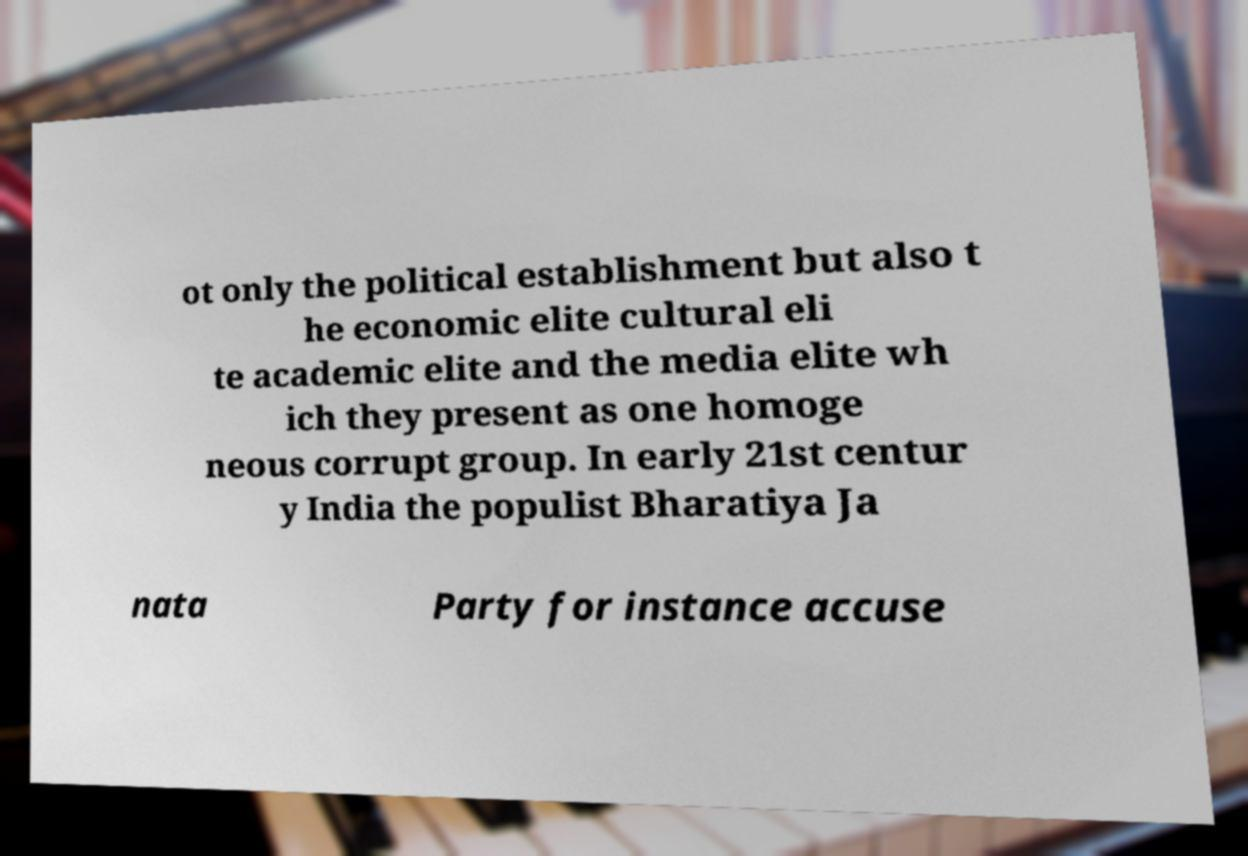There's text embedded in this image that I need extracted. Can you transcribe it verbatim? ot only the political establishment but also t he economic elite cultural eli te academic elite and the media elite wh ich they present as one homoge neous corrupt group. In early 21st centur y India the populist Bharatiya Ja nata Party for instance accuse 